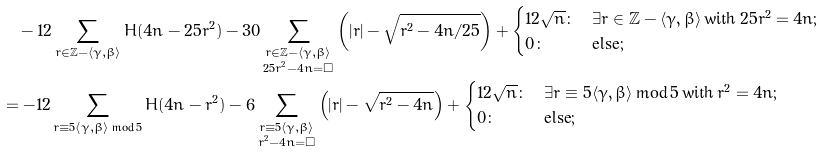<formula> <loc_0><loc_0><loc_500><loc_500>& \quad - 1 2 \sum _ { r \in \mathbb { Z } - \langle \gamma , \beta \rangle } H ( 4 n - 2 5 r ^ { 2 } ) - 3 0 \sum _ { \substack { r \in \mathbb { Z } - \langle \gamma , \beta \rangle \\ 2 5 r ^ { 2 } - 4 n = \square } } \left ( | r | - \sqrt { r ^ { 2 } - 4 n / 2 5 } \right ) + \begin{cases} 1 2 \sqrt { n } \colon & \exists r \in \mathbb { Z } - \langle \gamma , \beta \rangle \, \text {with} \, 2 5 r ^ { 2 } = 4 n ; \\ 0 \colon & \text {else} ; \end{cases} \\ & = - 1 2 \sum _ { r \equiv 5 \langle \gamma , \beta \rangle \, \text {mod} \, 5 } H ( 4 n - r ^ { 2 } ) - 6 \sum _ { \substack { r \equiv 5 \langle \gamma , \beta \rangle \\ r ^ { 2 } - 4 n = \square } } \left ( | r | - \sqrt { r ^ { 2 } - 4 n } \right ) + \begin{cases} 1 2 \sqrt { n } \colon & \exists r \equiv 5 \langle \gamma , \beta \rangle \, \text {mod} \, 5 \, \text {with} \, r ^ { 2 } = 4 n ; \\ 0 \colon & \text {else} ; \end{cases}</formula> 